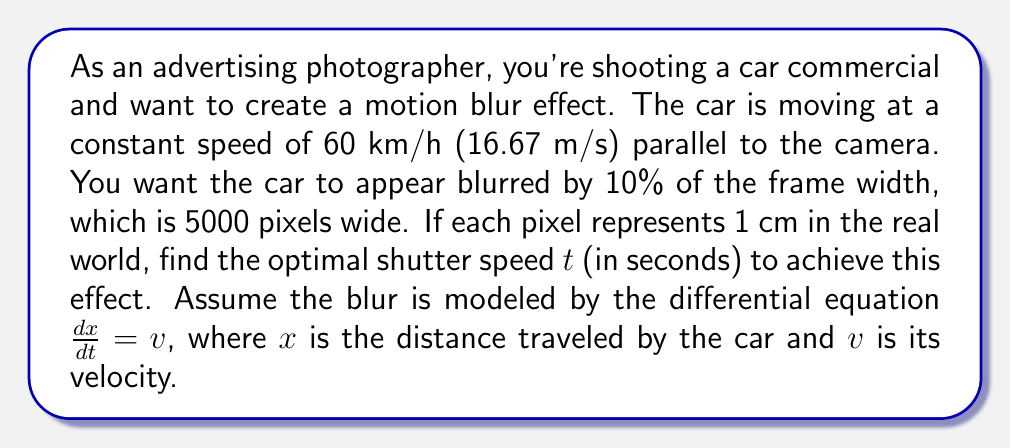Can you solve this math problem? To solve this problem, we'll follow these steps:

1) First, let's identify our known values:
   - Car speed: $v = 16.67$ m/s
   - Desired blur: 10% of 5000 pixels = 500 pixels
   - Each pixel represents 1 cm, so 500 pixels = 5 m

2) We're given the differential equation $\frac{dx}{dt} = v$. This is a first-order linear differential equation with constant coefficients.

3) To solve this, we integrate both sides:
   
   $$\int dx = \int v dt$$
   
   $$x = vt + C$$

   Where $C$ is the constant of integration.

4) We can ignore $C$ because we're only interested in the change in position (the blur distance), not the absolute position.

5) We want to find $t$ when $x = 5$ m (our desired blur distance):

   $$5 = 16.67t$$

6) Solving for $t$:

   $$t = \frac{5}{16.67} \approx 0.2999$$

7) Convert to milliseconds for typical shutter speed notation:

   $$0.2999 \text{ seconds} \approx 299.9 \text{ milliseconds}$$
Answer: The optimal shutter speed is approximately 1/3 second or 300 milliseconds. 